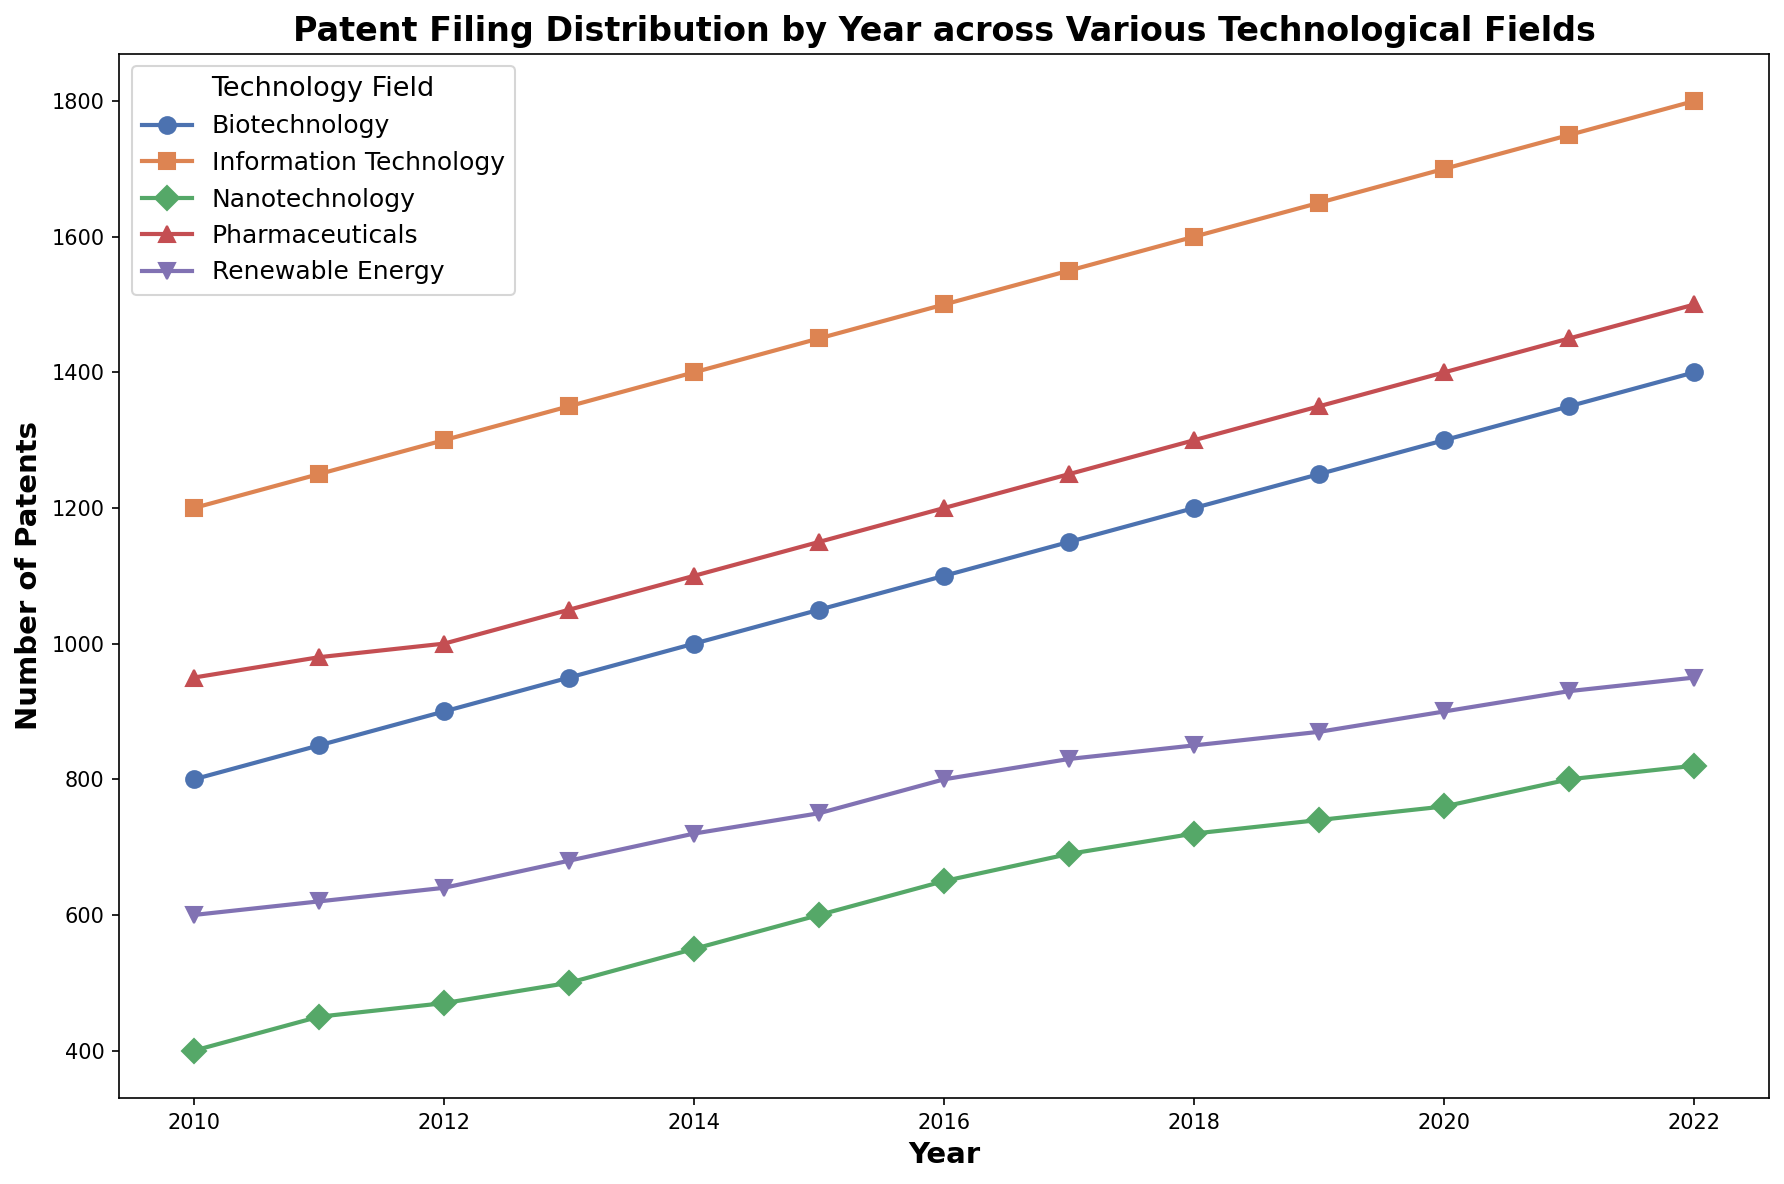Which technological field had the highest number of patent filings in 2022? By observing the plot, look for the year 2022 along the x-axis and identify which line reaches the highest value on the y-axis for that year. The highest point represents the field with the most patents.
Answer: Information Technology What is the total number of patents filed across all fields in 2015? Identify the number of patents for each technological field in 2015 by observing the plot's markers for that year. Sum the values of all the fields for 2015.
Answer: 1450 (IT) + 1050 (Biotechnology) + 750 (Renewable Energy) + 1150 (Pharmaceuticals) + 600 (Nanotechnology) = 5000 Which field had the least growth in patent filings from 2010 to 2022? Calculate the difference in the number of patents for each technological field between 2010 and 2022. The field with the smallest increase in values represents the least growth.
Answer: Nanotechnology (820 - 400 = 420) In which year did the Biotechnology sector first file over 1000 patents? Identify the line corresponding to Biotechnology and locate the year where the value exceeds 1000 for the first time.
Answer: 2015 Which field had the most consistent increase in patent filings over the years? Observe the trends of each field by examining the slopes of their respective lines. The field with a steady and near-linear increase represents the most consistent growth.
Answer: Information Technology Compare the total number of patents filed in Information Technology and Biotechnology in 2018. Which is higher and by how much? Note the number of patents for both fields in 2018 and compute their difference.
Answer: Information Technology is higher by 400 patents (1600 - 1200 = 400) What is the average number of patents filed in the Pharmaceutical field from 2010 to 2022? Sum the number of patents filed in Pharmaceuticals for each year from 2010 to 2022 and divide by the total number of years (13).
Answer: (950 + 980 + 1000 + 1050 + 1100 + 1150 + 1200 + 1250 + 1300 + 1350 + 1400 + 1450 + 1500) / 13 ≈ 1165 Which year had the smallest difference between the number of patents filed in Renewable Energy and Nanotechnology? Calculate the absolute differences between the number of patents filed in these two fields for each year and identify the year with the smallest difference.
Answer: 2011 (170) Are there any years where two or more technological fields had the same number of patents filed? Visually inspect the plot to check if there are any years where the markers for different fields align horizontally indicating the same number of patents.
Answer: No Which technological field exhibited more accelerated growth in patent filings from 2015 to 2020? Analyze the slopes of the lines from 2015 to 2020 for each field. The field with the steeper trend line demonstrates more accelerated growth.
Answer: Information Technology 